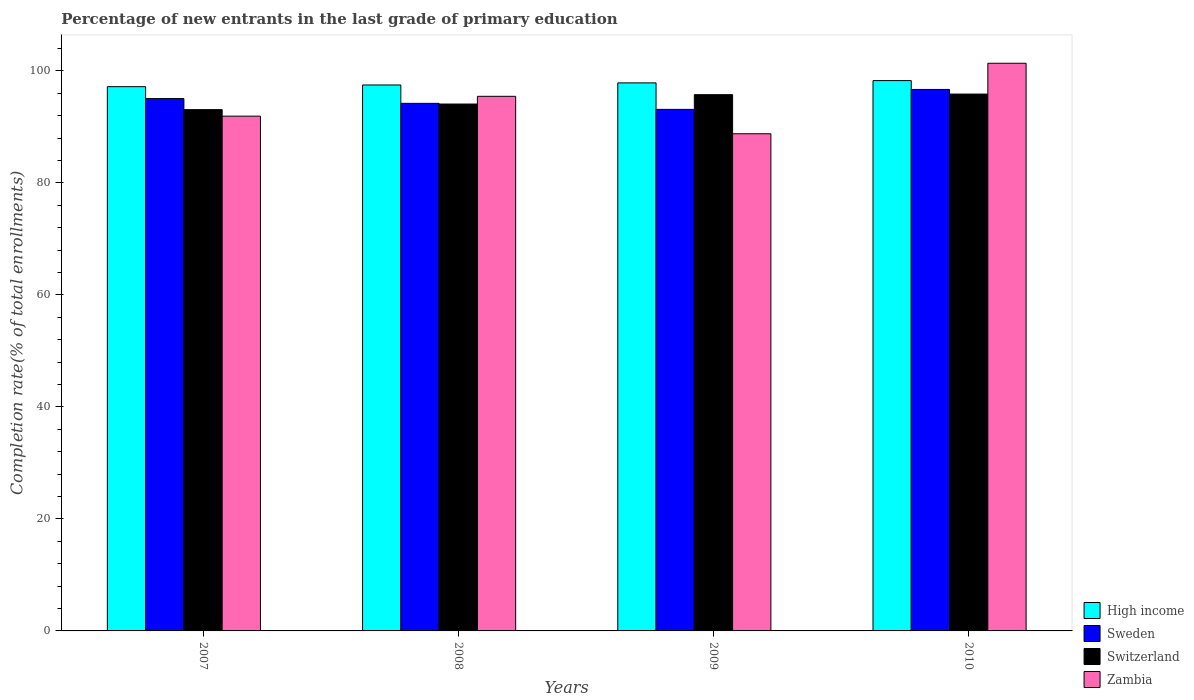How many different coloured bars are there?
Make the answer very short. 4. Are the number of bars per tick equal to the number of legend labels?
Keep it short and to the point. Yes. Are the number of bars on each tick of the X-axis equal?
Your answer should be compact. Yes. How many bars are there on the 1st tick from the left?
Provide a succinct answer. 4. What is the label of the 4th group of bars from the left?
Your answer should be compact. 2010. What is the percentage of new entrants in Sweden in 2009?
Your response must be concise. 93.14. Across all years, what is the maximum percentage of new entrants in Sweden?
Offer a terse response. 96.7. Across all years, what is the minimum percentage of new entrants in High income?
Keep it short and to the point. 97.2. In which year was the percentage of new entrants in Zambia maximum?
Give a very brief answer. 2010. In which year was the percentage of new entrants in Zambia minimum?
Give a very brief answer. 2009. What is the total percentage of new entrants in Sweden in the graph?
Offer a terse response. 379.14. What is the difference between the percentage of new entrants in Switzerland in 2007 and that in 2008?
Your response must be concise. -1. What is the difference between the percentage of new entrants in Switzerland in 2008 and the percentage of new entrants in Zambia in 2009?
Ensure brevity in your answer.  5.31. What is the average percentage of new entrants in Switzerland per year?
Keep it short and to the point. 94.71. In the year 2009, what is the difference between the percentage of new entrants in Switzerland and percentage of new entrants in Zambia?
Give a very brief answer. 6.98. In how many years, is the percentage of new entrants in Switzerland greater than 24 %?
Give a very brief answer. 4. What is the ratio of the percentage of new entrants in High income in 2008 to that in 2010?
Your answer should be very brief. 0.99. Is the percentage of new entrants in Switzerland in 2007 less than that in 2010?
Your answer should be compact. Yes. Is the difference between the percentage of new entrants in Switzerland in 2009 and 2010 greater than the difference between the percentage of new entrants in Zambia in 2009 and 2010?
Make the answer very short. Yes. What is the difference between the highest and the second highest percentage of new entrants in High income?
Give a very brief answer. 0.41. What is the difference between the highest and the lowest percentage of new entrants in Switzerland?
Give a very brief answer. 2.78. In how many years, is the percentage of new entrants in Switzerland greater than the average percentage of new entrants in Switzerland taken over all years?
Offer a terse response. 2. Is it the case that in every year, the sum of the percentage of new entrants in Zambia and percentage of new entrants in Sweden is greater than the sum of percentage of new entrants in High income and percentage of new entrants in Switzerland?
Make the answer very short. No. What does the 1st bar from the left in 2007 represents?
Your answer should be very brief. High income. What is the difference between two consecutive major ticks on the Y-axis?
Your answer should be very brief. 20. Does the graph contain any zero values?
Provide a succinct answer. No. Does the graph contain grids?
Offer a terse response. No. How many legend labels are there?
Your answer should be compact. 4. What is the title of the graph?
Offer a very short reply. Percentage of new entrants in the last grade of primary education. What is the label or title of the X-axis?
Give a very brief answer. Years. What is the label or title of the Y-axis?
Your answer should be compact. Completion rate(% of total enrollments). What is the Completion rate(% of total enrollments) of High income in 2007?
Your answer should be very brief. 97.2. What is the Completion rate(% of total enrollments) in Sweden in 2007?
Offer a terse response. 95.07. What is the Completion rate(% of total enrollments) of Switzerland in 2007?
Offer a terse response. 93.1. What is the Completion rate(% of total enrollments) of Zambia in 2007?
Your answer should be very brief. 91.93. What is the Completion rate(% of total enrollments) in High income in 2008?
Make the answer very short. 97.5. What is the Completion rate(% of total enrollments) in Sweden in 2008?
Offer a terse response. 94.22. What is the Completion rate(% of total enrollments) in Switzerland in 2008?
Offer a very short reply. 94.1. What is the Completion rate(% of total enrollments) of Zambia in 2008?
Make the answer very short. 95.47. What is the Completion rate(% of total enrollments) of High income in 2009?
Make the answer very short. 97.88. What is the Completion rate(% of total enrollments) in Sweden in 2009?
Make the answer very short. 93.14. What is the Completion rate(% of total enrollments) in Switzerland in 2009?
Provide a succinct answer. 95.77. What is the Completion rate(% of total enrollments) of Zambia in 2009?
Give a very brief answer. 88.79. What is the Completion rate(% of total enrollments) of High income in 2010?
Give a very brief answer. 98.28. What is the Completion rate(% of total enrollments) of Sweden in 2010?
Make the answer very short. 96.7. What is the Completion rate(% of total enrollments) in Switzerland in 2010?
Provide a short and direct response. 95.88. What is the Completion rate(% of total enrollments) in Zambia in 2010?
Offer a very short reply. 101.38. Across all years, what is the maximum Completion rate(% of total enrollments) in High income?
Ensure brevity in your answer.  98.28. Across all years, what is the maximum Completion rate(% of total enrollments) of Sweden?
Your answer should be compact. 96.7. Across all years, what is the maximum Completion rate(% of total enrollments) of Switzerland?
Give a very brief answer. 95.88. Across all years, what is the maximum Completion rate(% of total enrollments) in Zambia?
Your answer should be very brief. 101.38. Across all years, what is the minimum Completion rate(% of total enrollments) in High income?
Your response must be concise. 97.2. Across all years, what is the minimum Completion rate(% of total enrollments) of Sweden?
Provide a short and direct response. 93.14. Across all years, what is the minimum Completion rate(% of total enrollments) of Switzerland?
Provide a short and direct response. 93.1. Across all years, what is the minimum Completion rate(% of total enrollments) in Zambia?
Offer a terse response. 88.79. What is the total Completion rate(% of total enrollments) of High income in the graph?
Provide a succinct answer. 390.86. What is the total Completion rate(% of total enrollments) in Sweden in the graph?
Your answer should be compact. 379.14. What is the total Completion rate(% of total enrollments) in Switzerland in the graph?
Offer a very short reply. 378.84. What is the total Completion rate(% of total enrollments) of Zambia in the graph?
Offer a terse response. 377.58. What is the difference between the Completion rate(% of total enrollments) of High income in 2007 and that in 2008?
Offer a terse response. -0.3. What is the difference between the Completion rate(% of total enrollments) of Sweden in 2007 and that in 2008?
Provide a succinct answer. 0.85. What is the difference between the Completion rate(% of total enrollments) of Switzerland in 2007 and that in 2008?
Your response must be concise. -1. What is the difference between the Completion rate(% of total enrollments) of Zambia in 2007 and that in 2008?
Make the answer very short. -3.54. What is the difference between the Completion rate(% of total enrollments) of High income in 2007 and that in 2009?
Offer a terse response. -0.68. What is the difference between the Completion rate(% of total enrollments) of Sweden in 2007 and that in 2009?
Provide a short and direct response. 1.93. What is the difference between the Completion rate(% of total enrollments) of Switzerland in 2007 and that in 2009?
Your response must be concise. -2.67. What is the difference between the Completion rate(% of total enrollments) in Zambia in 2007 and that in 2009?
Offer a very short reply. 3.14. What is the difference between the Completion rate(% of total enrollments) in High income in 2007 and that in 2010?
Keep it short and to the point. -1.08. What is the difference between the Completion rate(% of total enrollments) of Sweden in 2007 and that in 2010?
Offer a very short reply. -1.63. What is the difference between the Completion rate(% of total enrollments) in Switzerland in 2007 and that in 2010?
Make the answer very short. -2.78. What is the difference between the Completion rate(% of total enrollments) in Zambia in 2007 and that in 2010?
Make the answer very short. -9.45. What is the difference between the Completion rate(% of total enrollments) of High income in 2008 and that in 2009?
Ensure brevity in your answer.  -0.37. What is the difference between the Completion rate(% of total enrollments) in Sweden in 2008 and that in 2009?
Give a very brief answer. 1.08. What is the difference between the Completion rate(% of total enrollments) in Switzerland in 2008 and that in 2009?
Provide a succinct answer. -1.67. What is the difference between the Completion rate(% of total enrollments) of Zambia in 2008 and that in 2009?
Make the answer very short. 6.68. What is the difference between the Completion rate(% of total enrollments) of High income in 2008 and that in 2010?
Offer a very short reply. -0.78. What is the difference between the Completion rate(% of total enrollments) of Sweden in 2008 and that in 2010?
Ensure brevity in your answer.  -2.49. What is the difference between the Completion rate(% of total enrollments) of Switzerland in 2008 and that in 2010?
Give a very brief answer. -1.78. What is the difference between the Completion rate(% of total enrollments) in Zambia in 2008 and that in 2010?
Provide a short and direct response. -5.91. What is the difference between the Completion rate(% of total enrollments) in High income in 2009 and that in 2010?
Ensure brevity in your answer.  -0.41. What is the difference between the Completion rate(% of total enrollments) of Sweden in 2009 and that in 2010?
Your answer should be compact. -3.56. What is the difference between the Completion rate(% of total enrollments) in Switzerland in 2009 and that in 2010?
Make the answer very short. -0.11. What is the difference between the Completion rate(% of total enrollments) in Zambia in 2009 and that in 2010?
Your answer should be very brief. -12.59. What is the difference between the Completion rate(% of total enrollments) of High income in 2007 and the Completion rate(% of total enrollments) of Sweden in 2008?
Make the answer very short. 2.98. What is the difference between the Completion rate(% of total enrollments) in High income in 2007 and the Completion rate(% of total enrollments) in Switzerland in 2008?
Your answer should be compact. 3.1. What is the difference between the Completion rate(% of total enrollments) in High income in 2007 and the Completion rate(% of total enrollments) in Zambia in 2008?
Ensure brevity in your answer.  1.72. What is the difference between the Completion rate(% of total enrollments) of Sweden in 2007 and the Completion rate(% of total enrollments) of Switzerland in 2008?
Provide a succinct answer. 0.97. What is the difference between the Completion rate(% of total enrollments) of Sweden in 2007 and the Completion rate(% of total enrollments) of Zambia in 2008?
Your answer should be compact. -0.4. What is the difference between the Completion rate(% of total enrollments) in Switzerland in 2007 and the Completion rate(% of total enrollments) in Zambia in 2008?
Give a very brief answer. -2.38. What is the difference between the Completion rate(% of total enrollments) in High income in 2007 and the Completion rate(% of total enrollments) in Sweden in 2009?
Keep it short and to the point. 4.06. What is the difference between the Completion rate(% of total enrollments) of High income in 2007 and the Completion rate(% of total enrollments) of Switzerland in 2009?
Offer a terse response. 1.43. What is the difference between the Completion rate(% of total enrollments) in High income in 2007 and the Completion rate(% of total enrollments) in Zambia in 2009?
Ensure brevity in your answer.  8.41. What is the difference between the Completion rate(% of total enrollments) in Sweden in 2007 and the Completion rate(% of total enrollments) in Switzerland in 2009?
Provide a short and direct response. -0.7. What is the difference between the Completion rate(% of total enrollments) of Sweden in 2007 and the Completion rate(% of total enrollments) of Zambia in 2009?
Keep it short and to the point. 6.28. What is the difference between the Completion rate(% of total enrollments) in Switzerland in 2007 and the Completion rate(% of total enrollments) in Zambia in 2009?
Your response must be concise. 4.31. What is the difference between the Completion rate(% of total enrollments) in High income in 2007 and the Completion rate(% of total enrollments) in Sweden in 2010?
Make the answer very short. 0.49. What is the difference between the Completion rate(% of total enrollments) of High income in 2007 and the Completion rate(% of total enrollments) of Switzerland in 2010?
Ensure brevity in your answer.  1.32. What is the difference between the Completion rate(% of total enrollments) in High income in 2007 and the Completion rate(% of total enrollments) in Zambia in 2010?
Your answer should be compact. -4.18. What is the difference between the Completion rate(% of total enrollments) of Sweden in 2007 and the Completion rate(% of total enrollments) of Switzerland in 2010?
Your answer should be compact. -0.81. What is the difference between the Completion rate(% of total enrollments) in Sweden in 2007 and the Completion rate(% of total enrollments) in Zambia in 2010?
Offer a terse response. -6.31. What is the difference between the Completion rate(% of total enrollments) of Switzerland in 2007 and the Completion rate(% of total enrollments) of Zambia in 2010?
Your response must be concise. -8.28. What is the difference between the Completion rate(% of total enrollments) of High income in 2008 and the Completion rate(% of total enrollments) of Sweden in 2009?
Make the answer very short. 4.36. What is the difference between the Completion rate(% of total enrollments) in High income in 2008 and the Completion rate(% of total enrollments) in Switzerland in 2009?
Your answer should be compact. 1.73. What is the difference between the Completion rate(% of total enrollments) of High income in 2008 and the Completion rate(% of total enrollments) of Zambia in 2009?
Give a very brief answer. 8.71. What is the difference between the Completion rate(% of total enrollments) of Sweden in 2008 and the Completion rate(% of total enrollments) of Switzerland in 2009?
Give a very brief answer. -1.55. What is the difference between the Completion rate(% of total enrollments) in Sweden in 2008 and the Completion rate(% of total enrollments) in Zambia in 2009?
Offer a very short reply. 5.43. What is the difference between the Completion rate(% of total enrollments) in Switzerland in 2008 and the Completion rate(% of total enrollments) in Zambia in 2009?
Your answer should be compact. 5.31. What is the difference between the Completion rate(% of total enrollments) of High income in 2008 and the Completion rate(% of total enrollments) of Sweden in 2010?
Your response must be concise. 0.8. What is the difference between the Completion rate(% of total enrollments) of High income in 2008 and the Completion rate(% of total enrollments) of Switzerland in 2010?
Keep it short and to the point. 1.62. What is the difference between the Completion rate(% of total enrollments) of High income in 2008 and the Completion rate(% of total enrollments) of Zambia in 2010?
Make the answer very short. -3.88. What is the difference between the Completion rate(% of total enrollments) of Sweden in 2008 and the Completion rate(% of total enrollments) of Switzerland in 2010?
Provide a short and direct response. -1.66. What is the difference between the Completion rate(% of total enrollments) of Sweden in 2008 and the Completion rate(% of total enrollments) of Zambia in 2010?
Ensure brevity in your answer.  -7.16. What is the difference between the Completion rate(% of total enrollments) of Switzerland in 2008 and the Completion rate(% of total enrollments) of Zambia in 2010?
Make the answer very short. -7.28. What is the difference between the Completion rate(% of total enrollments) in High income in 2009 and the Completion rate(% of total enrollments) in Sweden in 2010?
Your answer should be very brief. 1.17. What is the difference between the Completion rate(% of total enrollments) of High income in 2009 and the Completion rate(% of total enrollments) of Switzerland in 2010?
Provide a succinct answer. 2. What is the difference between the Completion rate(% of total enrollments) in High income in 2009 and the Completion rate(% of total enrollments) in Zambia in 2010?
Give a very brief answer. -3.5. What is the difference between the Completion rate(% of total enrollments) of Sweden in 2009 and the Completion rate(% of total enrollments) of Switzerland in 2010?
Give a very brief answer. -2.74. What is the difference between the Completion rate(% of total enrollments) in Sweden in 2009 and the Completion rate(% of total enrollments) in Zambia in 2010?
Keep it short and to the point. -8.24. What is the difference between the Completion rate(% of total enrollments) of Switzerland in 2009 and the Completion rate(% of total enrollments) of Zambia in 2010?
Your answer should be compact. -5.61. What is the average Completion rate(% of total enrollments) of High income per year?
Your response must be concise. 97.71. What is the average Completion rate(% of total enrollments) in Sweden per year?
Your response must be concise. 94.78. What is the average Completion rate(% of total enrollments) in Switzerland per year?
Your answer should be compact. 94.71. What is the average Completion rate(% of total enrollments) of Zambia per year?
Make the answer very short. 94.39. In the year 2007, what is the difference between the Completion rate(% of total enrollments) in High income and Completion rate(% of total enrollments) in Sweden?
Provide a succinct answer. 2.13. In the year 2007, what is the difference between the Completion rate(% of total enrollments) in High income and Completion rate(% of total enrollments) in Switzerland?
Provide a succinct answer. 4.1. In the year 2007, what is the difference between the Completion rate(% of total enrollments) of High income and Completion rate(% of total enrollments) of Zambia?
Offer a terse response. 5.27. In the year 2007, what is the difference between the Completion rate(% of total enrollments) in Sweden and Completion rate(% of total enrollments) in Switzerland?
Keep it short and to the point. 1.98. In the year 2007, what is the difference between the Completion rate(% of total enrollments) in Sweden and Completion rate(% of total enrollments) in Zambia?
Your answer should be compact. 3.14. In the year 2007, what is the difference between the Completion rate(% of total enrollments) of Switzerland and Completion rate(% of total enrollments) of Zambia?
Provide a succinct answer. 1.16. In the year 2008, what is the difference between the Completion rate(% of total enrollments) in High income and Completion rate(% of total enrollments) in Sweden?
Your answer should be very brief. 3.28. In the year 2008, what is the difference between the Completion rate(% of total enrollments) of High income and Completion rate(% of total enrollments) of Switzerland?
Your response must be concise. 3.4. In the year 2008, what is the difference between the Completion rate(% of total enrollments) in High income and Completion rate(% of total enrollments) in Zambia?
Provide a short and direct response. 2.03. In the year 2008, what is the difference between the Completion rate(% of total enrollments) of Sweden and Completion rate(% of total enrollments) of Switzerland?
Ensure brevity in your answer.  0.12. In the year 2008, what is the difference between the Completion rate(% of total enrollments) of Sweden and Completion rate(% of total enrollments) of Zambia?
Offer a terse response. -1.26. In the year 2008, what is the difference between the Completion rate(% of total enrollments) in Switzerland and Completion rate(% of total enrollments) in Zambia?
Keep it short and to the point. -1.38. In the year 2009, what is the difference between the Completion rate(% of total enrollments) in High income and Completion rate(% of total enrollments) in Sweden?
Your answer should be compact. 4.73. In the year 2009, what is the difference between the Completion rate(% of total enrollments) in High income and Completion rate(% of total enrollments) in Switzerland?
Provide a short and direct response. 2.11. In the year 2009, what is the difference between the Completion rate(% of total enrollments) in High income and Completion rate(% of total enrollments) in Zambia?
Keep it short and to the point. 9.09. In the year 2009, what is the difference between the Completion rate(% of total enrollments) of Sweden and Completion rate(% of total enrollments) of Switzerland?
Your answer should be very brief. -2.63. In the year 2009, what is the difference between the Completion rate(% of total enrollments) of Sweden and Completion rate(% of total enrollments) of Zambia?
Keep it short and to the point. 4.35. In the year 2009, what is the difference between the Completion rate(% of total enrollments) in Switzerland and Completion rate(% of total enrollments) in Zambia?
Offer a very short reply. 6.98. In the year 2010, what is the difference between the Completion rate(% of total enrollments) in High income and Completion rate(% of total enrollments) in Sweden?
Provide a succinct answer. 1.58. In the year 2010, what is the difference between the Completion rate(% of total enrollments) of High income and Completion rate(% of total enrollments) of Switzerland?
Your answer should be compact. 2.4. In the year 2010, what is the difference between the Completion rate(% of total enrollments) of High income and Completion rate(% of total enrollments) of Zambia?
Make the answer very short. -3.1. In the year 2010, what is the difference between the Completion rate(% of total enrollments) of Sweden and Completion rate(% of total enrollments) of Switzerland?
Your answer should be very brief. 0.83. In the year 2010, what is the difference between the Completion rate(% of total enrollments) in Sweden and Completion rate(% of total enrollments) in Zambia?
Your answer should be compact. -4.68. In the year 2010, what is the difference between the Completion rate(% of total enrollments) in Switzerland and Completion rate(% of total enrollments) in Zambia?
Provide a succinct answer. -5.5. What is the ratio of the Completion rate(% of total enrollments) of High income in 2007 to that in 2008?
Provide a succinct answer. 1. What is the ratio of the Completion rate(% of total enrollments) in Sweden in 2007 to that in 2008?
Your answer should be very brief. 1.01. What is the ratio of the Completion rate(% of total enrollments) in Zambia in 2007 to that in 2008?
Your answer should be compact. 0.96. What is the ratio of the Completion rate(% of total enrollments) in High income in 2007 to that in 2009?
Provide a short and direct response. 0.99. What is the ratio of the Completion rate(% of total enrollments) of Sweden in 2007 to that in 2009?
Provide a short and direct response. 1.02. What is the ratio of the Completion rate(% of total enrollments) in Switzerland in 2007 to that in 2009?
Offer a very short reply. 0.97. What is the ratio of the Completion rate(% of total enrollments) in Zambia in 2007 to that in 2009?
Give a very brief answer. 1.04. What is the ratio of the Completion rate(% of total enrollments) in Sweden in 2007 to that in 2010?
Offer a terse response. 0.98. What is the ratio of the Completion rate(% of total enrollments) in Zambia in 2007 to that in 2010?
Keep it short and to the point. 0.91. What is the ratio of the Completion rate(% of total enrollments) in High income in 2008 to that in 2009?
Make the answer very short. 1. What is the ratio of the Completion rate(% of total enrollments) in Sweden in 2008 to that in 2009?
Your answer should be very brief. 1.01. What is the ratio of the Completion rate(% of total enrollments) in Switzerland in 2008 to that in 2009?
Your answer should be compact. 0.98. What is the ratio of the Completion rate(% of total enrollments) in Zambia in 2008 to that in 2009?
Keep it short and to the point. 1.08. What is the ratio of the Completion rate(% of total enrollments) in Sweden in 2008 to that in 2010?
Your response must be concise. 0.97. What is the ratio of the Completion rate(% of total enrollments) of Switzerland in 2008 to that in 2010?
Make the answer very short. 0.98. What is the ratio of the Completion rate(% of total enrollments) in Zambia in 2008 to that in 2010?
Offer a terse response. 0.94. What is the ratio of the Completion rate(% of total enrollments) of Sweden in 2009 to that in 2010?
Your answer should be compact. 0.96. What is the ratio of the Completion rate(% of total enrollments) in Switzerland in 2009 to that in 2010?
Make the answer very short. 1. What is the ratio of the Completion rate(% of total enrollments) in Zambia in 2009 to that in 2010?
Offer a very short reply. 0.88. What is the difference between the highest and the second highest Completion rate(% of total enrollments) of High income?
Ensure brevity in your answer.  0.41. What is the difference between the highest and the second highest Completion rate(% of total enrollments) in Sweden?
Make the answer very short. 1.63. What is the difference between the highest and the second highest Completion rate(% of total enrollments) in Switzerland?
Offer a terse response. 0.11. What is the difference between the highest and the second highest Completion rate(% of total enrollments) in Zambia?
Give a very brief answer. 5.91. What is the difference between the highest and the lowest Completion rate(% of total enrollments) of High income?
Provide a short and direct response. 1.08. What is the difference between the highest and the lowest Completion rate(% of total enrollments) in Sweden?
Offer a terse response. 3.56. What is the difference between the highest and the lowest Completion rate(% of total enrollments) of Switzerland?
Provide a short and direct response. 2.78. What is the difference between the highest and the lowest Completion rate(% of total enrollments) in Zambia?
Make the answer very short. 12.59. 